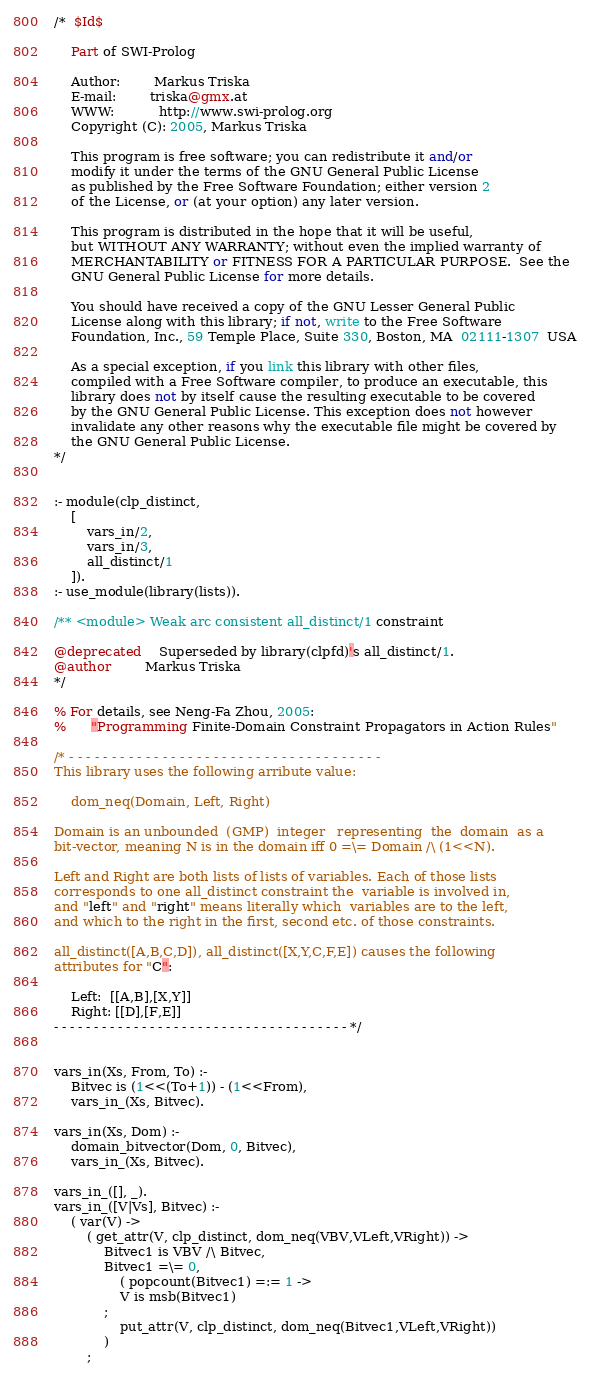<code> <loc_0><loc_0><loc_500><loc_500><_Perl_>/*  $Id$

    Part of SWI-Prolog

    Author:        Markus Triska
    E-mail:        triska@gmx.at
    WWW:           http://www.swi-prolog.org
    Copyright (C): 2005, Markus Triska

    This program is free software; you can redistribute it and/or
    modify it under the terms of the GNU General Public License
    as published by the Free Software Foundation; either version 2
    of the License, or (at your option) any later version.

    This program is distributed in the hope that it will be useful,
    but WITHOUT ANY WARRANTY; without even the implied warranty of
    MERCHANTABILITY or FITNESS FOR A PARTICULAR PURPOSE.  See the
    GNU General Public License for more details.

    You should have received a copy of the GNU Lesser General Public
    License along with this library; if not, write to the Free Software
    Foundation, Inc., 59 Temple Place, Suite 330, Boston, MA  02111-1307  USA

    As a special exception, if you link this library with other files,
    compiled with a Free Software compiler, to produce an executable, this
    library does not by itself cause the resulting executable to be covered
    by the GNU General Public License. This exception does not however
    invalidate any other reasons why the executable file might be covered by
    the GNU General Public License.
*/


:- module(clp_distinct,
	[
		vars_in/2,
		vars_in/3,
		all_distinct/1
	]).
:- use_module(library(lists)).

/** <module> Weak arc consistent all_distinct/1 constraint

@deprecated	Superseded by library(clpfd)'s all_distinct/1.
@author		Markus Triska
*/

% For details, see Neng-Fa Zhou, 2005:
%      "Programming Finite-Domain Constraint Propagators in Action Rules"

/* - - - - - - - - - - - - - - - - - - - - - - - - - - - - - - - - - - - - -
This library uses the following arribute value:

	dom_neq(Domain, Left, Right)

Domain is an unbounded  (GMP)  integer   representing  the  domain  as a
bit-vector, meaning N is in the domain iff 0 =\= Domain /\ (1<<N).

Left and Right are both lists of lists of variables. Each of those lists
corresponds to one all_distinct constraint the  variable is involved in,
and "left" and "right" means literally which  variables are to the left,
and which to the right in the first, second etc. of those constraints.

all_distinct([A,B,C,D]), all_distinct([X,Y,C,F,E]) causes the following
attributes for "C":

	Left:  [[A,B],[X,Y]]
	Right: [[D],[F,E]]
- - - - - - - - - - - - - - - - - - - - - - - - - - - - - - - - - - - - - */


vars_in(Xs, From, To) :-
	Bitvec is (1<<(To+1)) - (1<<From),
	vars_in_(Xs, Bitvec).

vars_in(Xs, Dom) :-
	domain_bitvector(Dom, 0, Bitvec),
	vars_in_(Xs, Bitvec).

vars_in_([], _).
vars_in_([V|Vs], Bitvec) :-
	( var(V) ->
		( get_attr(V, clp_distinct, dom_neq(VBV,VLeft,VRight)) ->
			Bitvec1 is VBV /\ Bitvec,
		  	Bitvec1 =\= 0,
		        ( popcount(Bitvec1) =:= 1 ->
				V is msb(Bitvec1)
			;
				put_attr(V, clp_distinct, dom_neq(Bitvec1,VLeft,VRight))
			)
		;</code> 